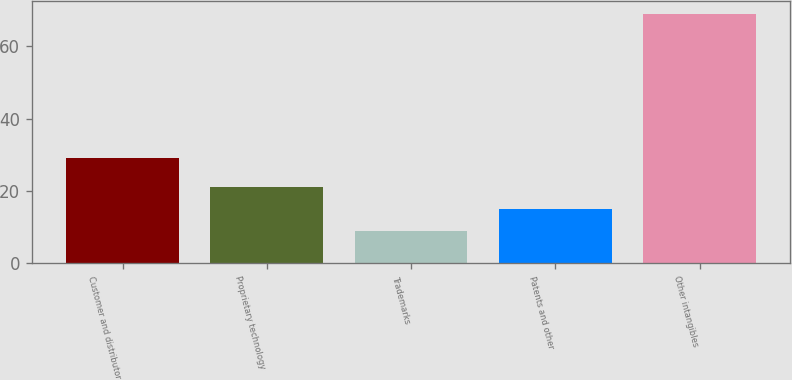<chart> <loc_0><loc_0><loc_500><loc_500><bar_chart><fcel>Customer and distributor<fcel>Proprietary technology<fcel>Trademarks<fcel>Patents and other<fcel>Other intangibles<nl><fcel>29<fcel>21<fcel>9<fcel>15<fcel>69<nl></chart> 